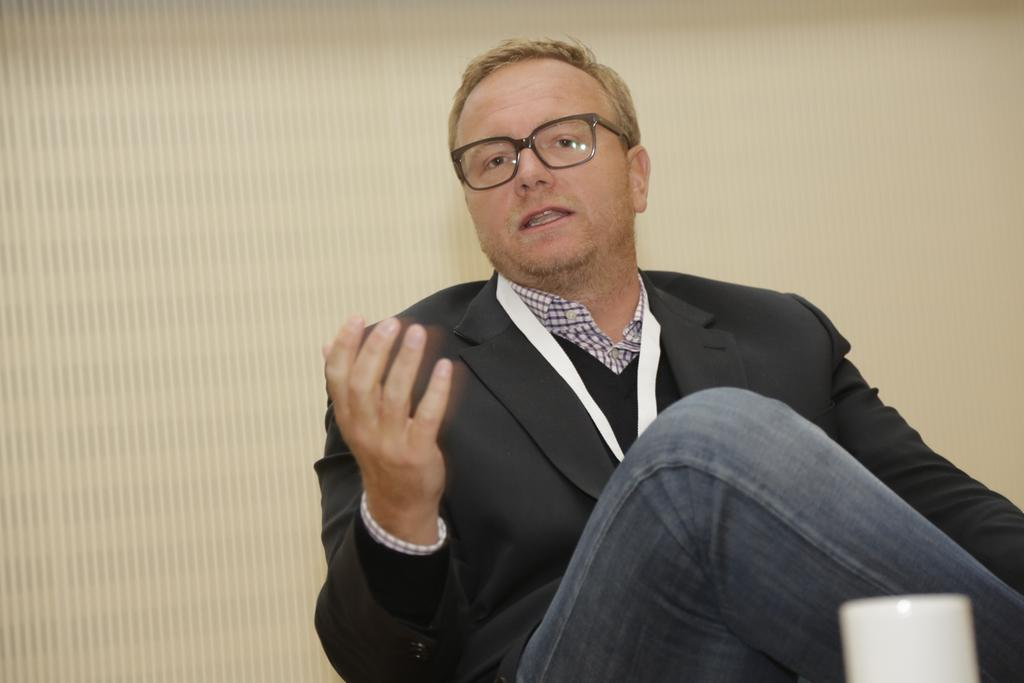Who is the main subject in the picture? There is a man in the middle of the picture. What is the man wearing in the image? The man is wearing a coat and spectacles. What can be seen in the background of the picture? There is a wall in the background of the picture. What type of ray is swimming near the man in the image? There is no ray present in the image; it is a man standing in front of a wall. Who is the man's partner in the image? The image does not show the man with a partner, so it cannot be determined from the image. 